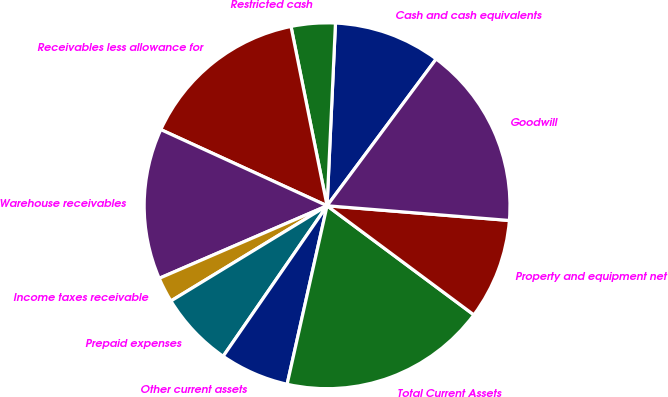<chart> <loc_0><loc_0><loc_500><loc_500><pie_chart><fcel>Cash and cash equivalents<fcel>Restricted cash<fcel>Receivables less allowance for<fcel>Warehouse receivables<fcel>Income taxes receivable<fcel>Prepaid expenses<fcel>Other current assets<fcel>Total Current Assets<fcel>Property and equipment net<fcel>Goodwill<nl><fcel>9.44%<fcel>3.89%<fcel>15.0%<fcel>13.33%<fcel>2.22%<fcel>6.67%<fcel>6.11%<fcel>18.33%<fcel>8.89%<fcel>16.11%<nl></chart> 